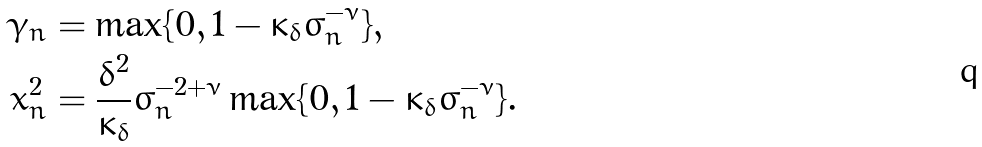Convert formula to latex. <formula><loc_0><loc_0><loc_500><loc_500>\bar { \gamma } _ { n } & = \max \{ 0 , 1 - \kappa _ { \delta } \sigma _ { n } ^ { - \nu } \} , \\ \bar { x } _ { n } ^ { 2 } & = \frac { \delta ^ { 2 } } { \kappa _ { \delta } } \sigma _ { n } ^ { - 2 + \nu } \max \{ 0 , 1 - \kappa _ { \delta } \sigma _ { n } ^ { - \nu } \} .</formula> 